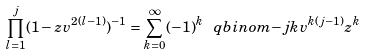<formula> <loc_0><loc_0><loc_500><loc_500>\prod _ { l = 1 } ^ { j } ( 1 - z v ^ { 2 ( l - 1 ) } ) ^ { - 1 } = \sum _ { k = 0 } ^ { \infty } ( - 1 ) ^ { k } \ q b i n o m { - j } { k } v ^ { k ( j - 1 ) } z ^ { k }</formula> 